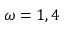Convert formula to latex. <formula><loc_0><loc_0><loc_500><loc_500>\omega = 1 , 4</formula> 